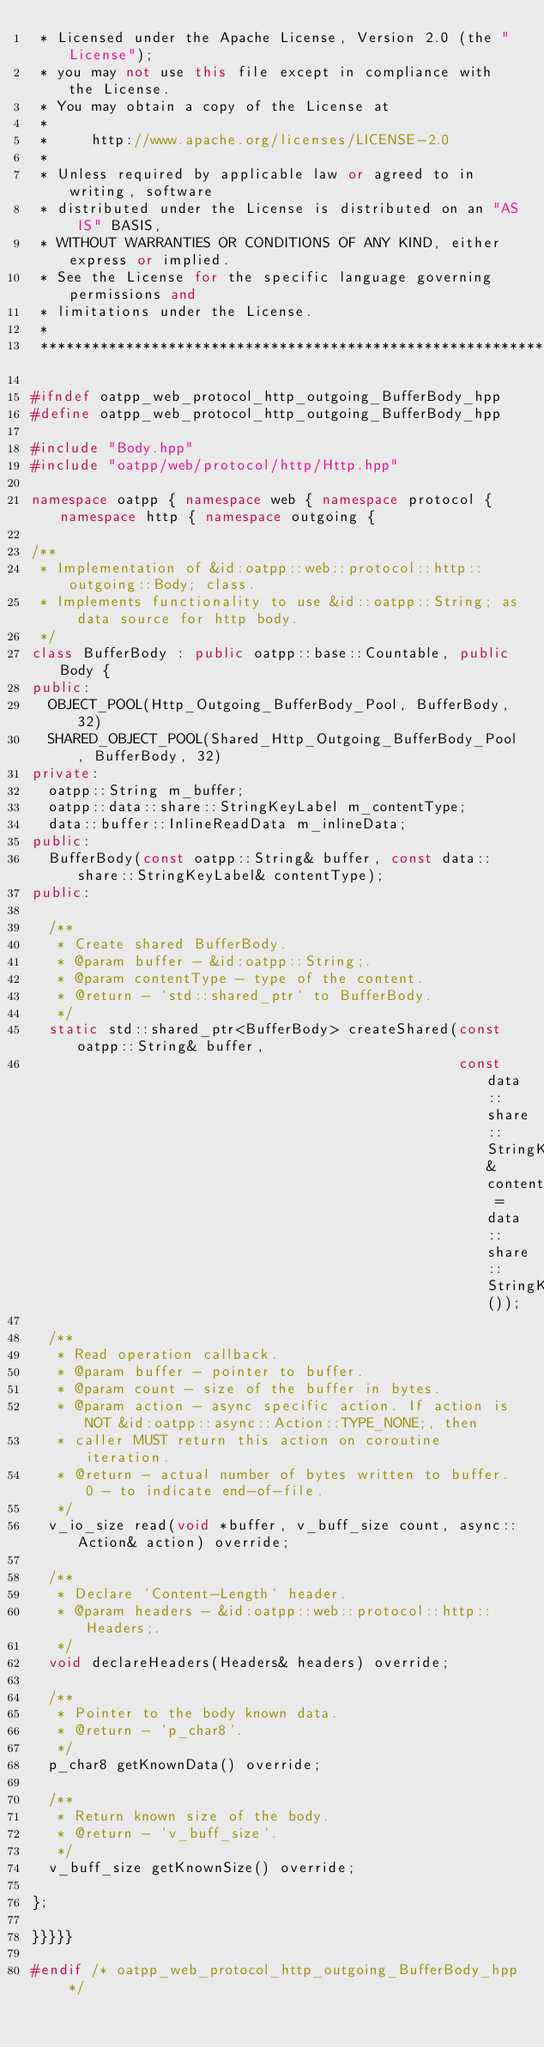Convert code to text. <code><loc_0><loc_0><loc_500><loc_500><_C++_> * Licensed under the Apache License, Version 2.0 (the "License");
 * you may not use this file except in compliance with the License.
 * You may obtain a copy of the License at
 *
 *     http://www.apache.org/licenses/LICENSE-2.0
 *
 * Unless required by applicable law or agreed to in writing, software
 * distributed under the License is distributed on an "AS IS" BASIS,
 * WITHOUT WARRANTIES OR CONDITIONS OF ANY KIND, either express or implied.
 * See the License for the specific language governing permissions and
 * limitations under the License.
 *
 ***************************************************************************/

#ifndef oatpp_web_protocol_http_outgoing_BufferBody_hpp
#define oatpp_web_protocol_http_outgoing_BufferBody_hpp

#include "Body.hpp"
#include "oatpp/web/protocol/http/Http.hpp"

namespace oatpp { namespace web { namespace protocol { namespace http { namespace outgoing {

/**
 * Implementation of &id:oatpp::web::protocol::http::outgoing::Body; class.
 * Implements functionality to use &id::oatpp::String; as data source for http body.
 */
class BufferBody : public oatpp::base::Countable, public Body {
public:
  OBJECT_POOL(Http_Outgoing_BufferBody_Pool, BufferBody, 32)
  SHARED_OBJECT_POOL(Shared_Http_Outgoing_BufferBody_Pool, BufferBody, 32)
private:
  oatpp::String m_buffer;
  oatpp::data::share::StringKeyLabel m_contentType;
  data::buffer::InlineReadData m_inlineData;
public:
  BufferBody(const oatpp::String& buffer, const data::share::StringKeyLabel& contentType);
public:

  /**
   * Create shared BufferBody.
   * @param buffer - &id:oatpp::String;.
   * @param contentType - type of the content.
   * @return - `std::shared_ptr` to BufferBody.
   */
  static std::shared_ptr<BufferBody> createShared(const oatpp::String& buffer,
                                                  const data::share::StringKeyLabel& contentType = data::share::StringKeyLabel());

  /**
   * Read operation callback.
   * @param buffer - pointer to buffer.
   * @param count - size of the buffer in bytes.
   * @param action - async specific action. If action is NOT &id:oatpp::async::Action::TYPE_NONE;, then
   * caller MUST return this action on coroutine iteration.
   * @return - actual number of bytes written to buffer. 0 - to indicate end-of-file.
   */
  v_io_size read(void *buffer, v_buff_size count, async::Action& action) override;

  /**
   * Declare `Content-Length` header.
   * @param headers - &id:oatpp::web::protocol::http::Headers;.
   */
  void declareHeaders(Headers& headers) override;

  /**
   * Pointer to the body known data.
   * @return - `p_char8`.
   */
  p_char8 getKnownData() override;

  /**
   * Return known size of the body.
   * @return - `v_buff_size`.
   */
  v_buff_size getKnownSize() override;
  
};
  
}}}}}

#endif /* oatpp_web_protocol_http_outgoing_BufferBody_hpp */
</code> 